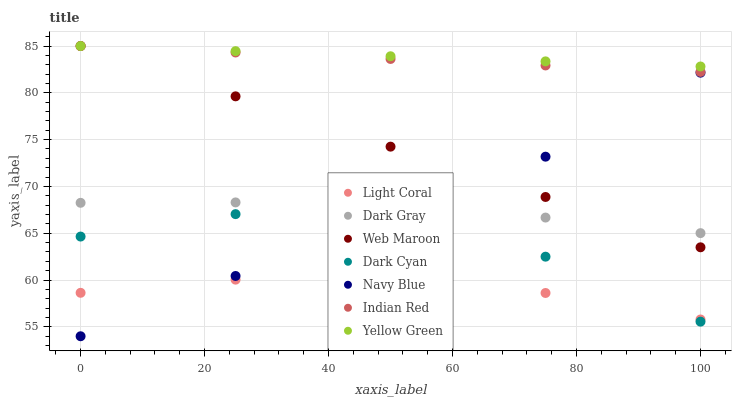Does Light Coral have the minimum area under the curve?
Answer yes or no. Yes. Does Yellow Green have the maximum area under the curve?
Answer yes or no. Yes. Does Navy Blue have the minimum area under the curve?
Answer yes or no. No. Does Navy Blue have the maximum area under the curve?
Answer yes or no. No. Is Yellow Green the smoothest?
Answer yes or no. Yes. Is Dark Cyan the roughest?
Answer yes or no. Yes. Is Navy Blue the smoothest?
Answer yes or no. No. Is Navy Blue the roughest?
Answer yes or no. No. Does Navy Blue have the lowest value?
Answer yes or no. Yes. Does Yellow Green have the lowest value?
Answer yes or no. No. Does Indian Red have the highest value?
Answer yes or no. Yes. Does Navy Blue have the highest value?
Answer yes or no. No. Is Light Coral less than Web Maroon?
Answer yes or no. Yes. Is Web Maroon greater than Dark Cyan?
Answer yes or no. Yes. Does Light Coral intersect Dark Cyan?
Answer yes or no. Yes. Is Light Coral less than Dark Cyan?
Answer yes or no. No. Is Light Coral greater than Dark Cyan?
Answer yes or no. No. Does Light Coral intersect Web Maroon?
Answer yes or no. No. 